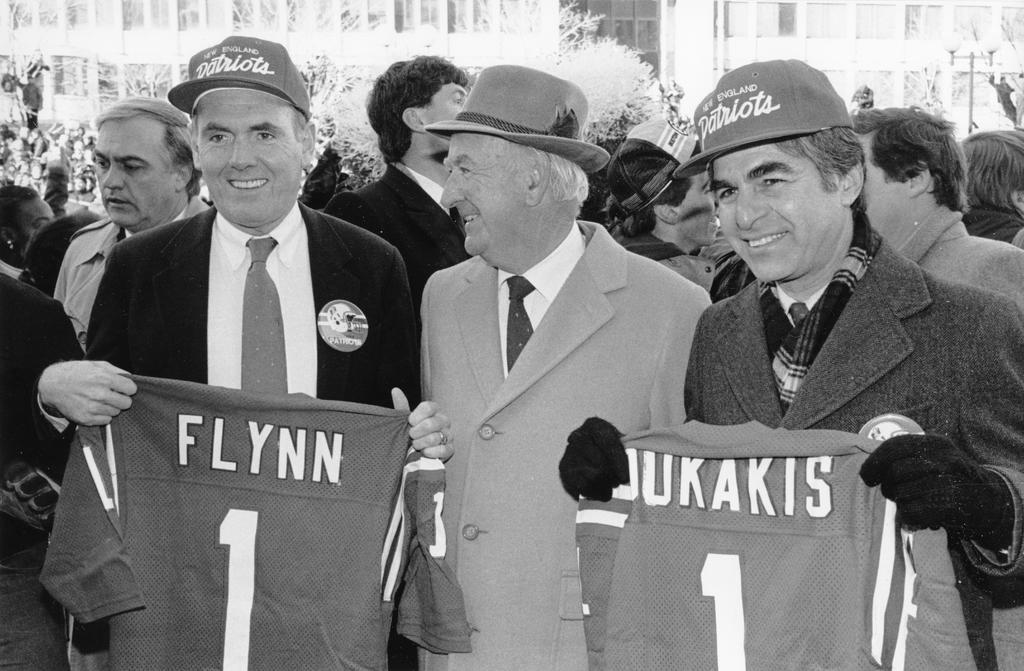What is happening in the image? There is a group of people standing in the image. What are two people in the group doing? Two people in the group are holding shirts in the image. Can you describe the background of the image? The background of the image is not clear. How many pies are being baked by the group in the image? There are no pies or baking activity present in the image. 